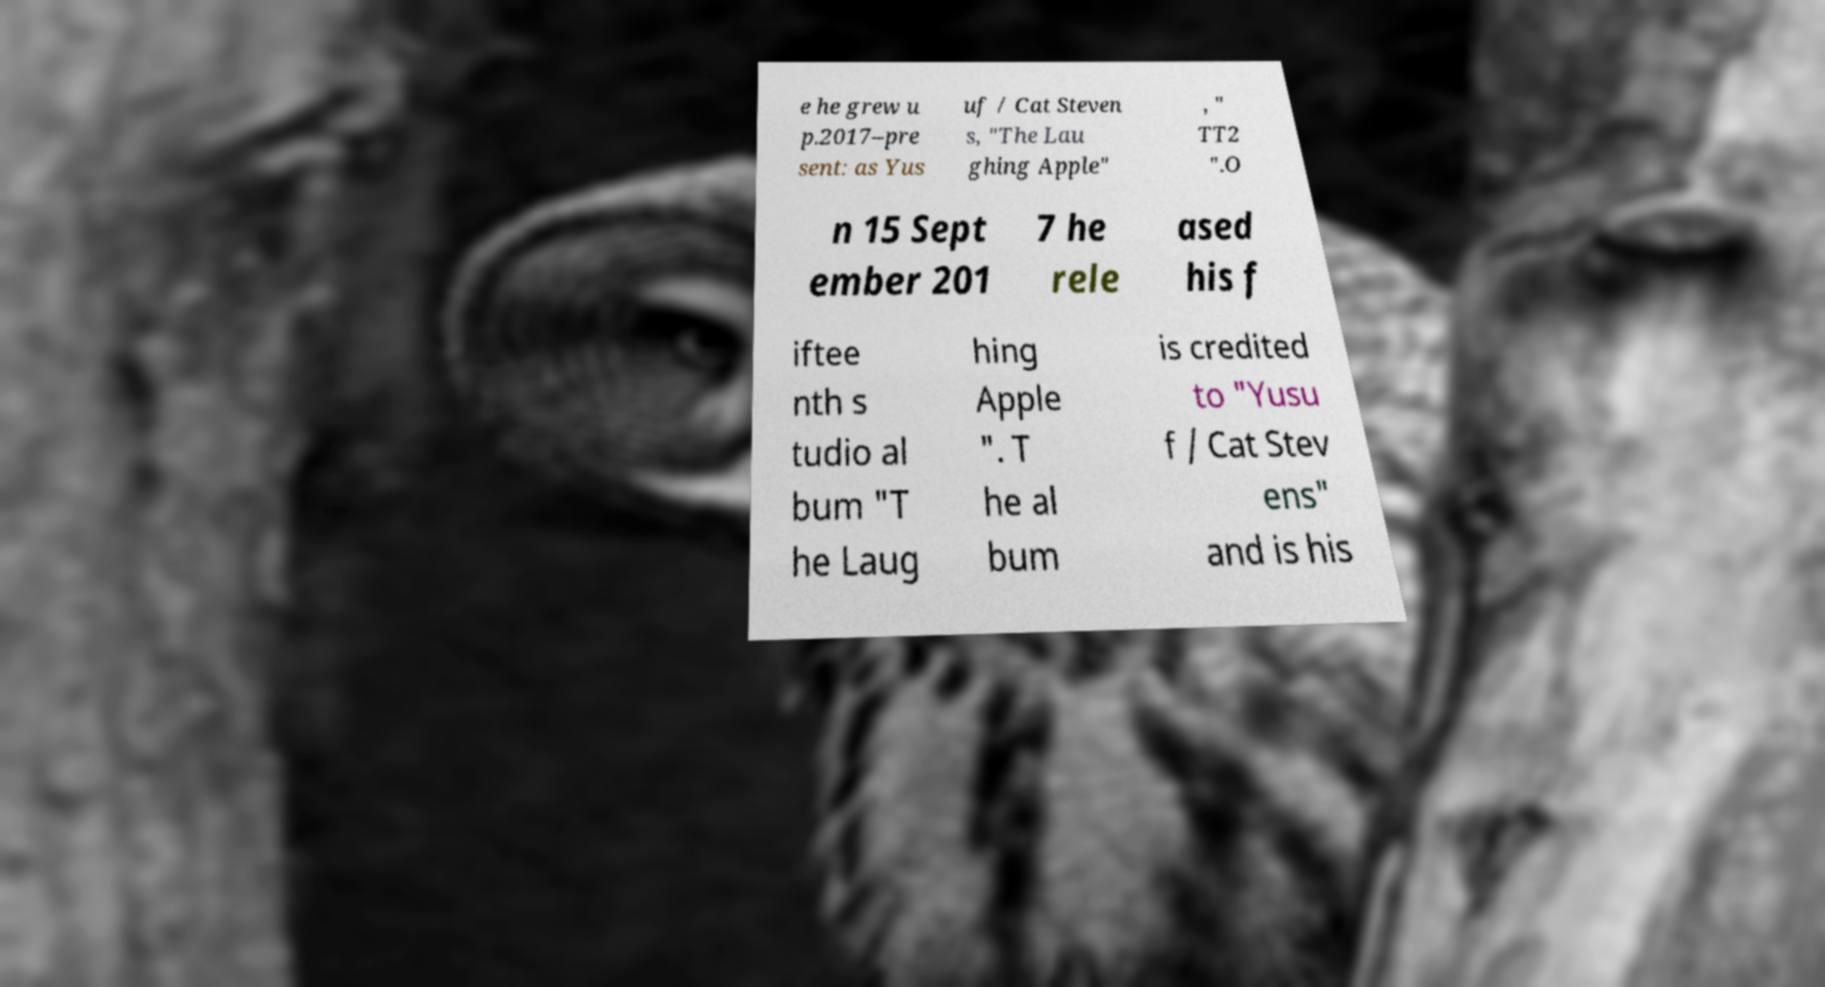Could you assist in decoding the text presented in this image and type it out clearly? e he grew u p.2017–pre sent: as Yus uf / Cat Steven s, "The Lau ghing Apple" , " TT2 ".O n 15 Sept ember 201 7 he rele ased his f iftee nth s tudio al bum "T he Laug hing Apple ". T he al bum is credited to "Yusu f / Cat Stev ens" and is his 